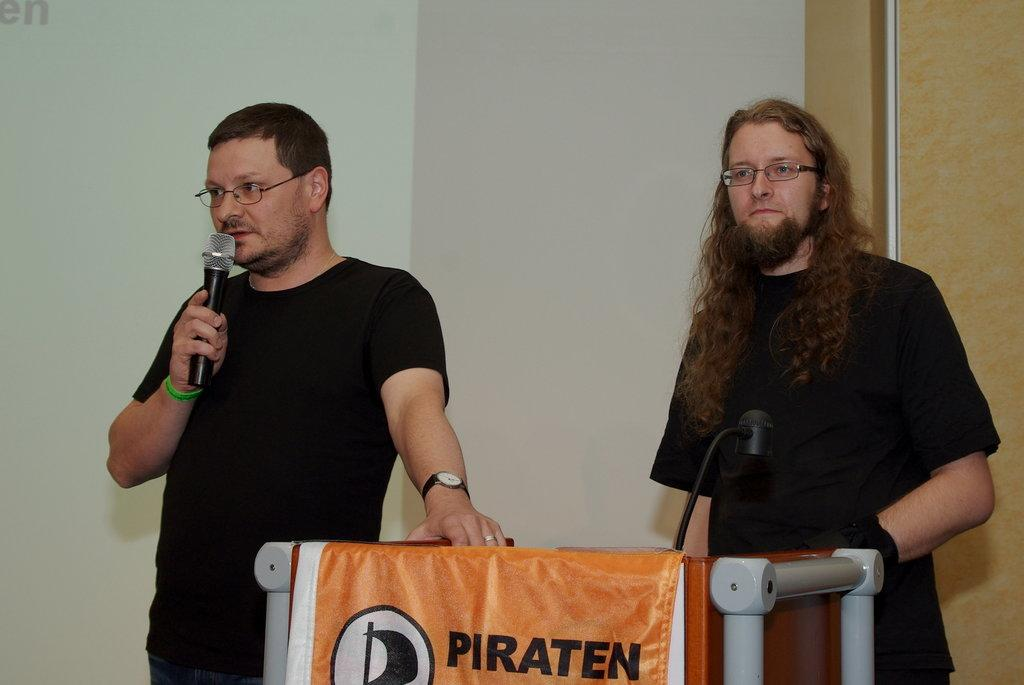What is the person on the left side of the image doing? The person on the left is speaking into a microphone. What is the position of the person on the right side of the image? The person on the right is standing. What is present between the two people in the image? There is a wooden stand in front of the two people. What can be seen on the wooden stand? There is writing on the wooden stand. What type of belief is depicted on the wall in the image? There is no wall present in the image, and therefore no belief can be depicted on it. 